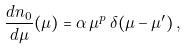Convert formula to latex. <formula><loc_0><loc_0><loc_500><loc_500>\frac { d n _ { 0 } } { d \mu } ( \mu ) = \alpha \, \mu ^ { p } \, \delta ( \mu - \mu ^ { \prime } ) \, ,</formula> 